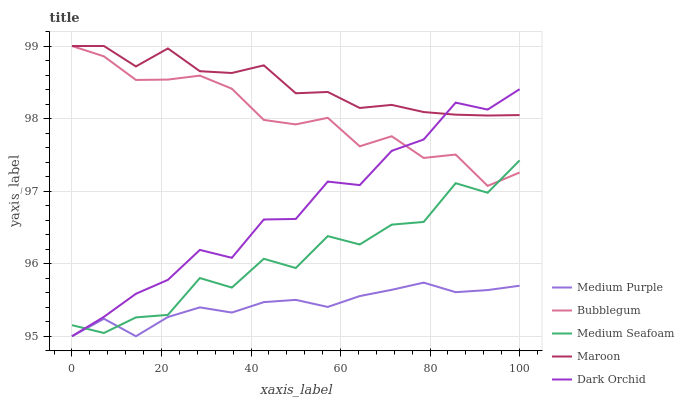Does Medium Purple have the minimum area under the curve?
Answer yes or no. Yes. Does Maroon have the maximum area under the curve?
Answer yes or no. Yes. Does Dark Orchid have the minimum area under the curve?
Answer yes or no. No. Does Dark Orchid have the maximum area under the curve?
Answer yes or no. No. Is Medium Purple the smoothest?
Answer yes or no. Yes. Is Medium Seafoam the roughest?
Answer yes or no. Yes. Is Maroon the smoothest?
Answer yes or no. No. Is Maroon the roughest?
Answer yes or no. No. Does Medium Purple have the lowest value?
Answer yes or no. Yes. Does Maroon have the lowest value?
Answer yes or no. No. Does Bubblegum have the highest value?
Answer yes or no. Yes. Does Dark Orchid have the highest value?
Answer yes or no. No. Is Medium Seafoam less than Maroon?
Answer yes or no. Yes. Is Bubblegum greater than Medium Purple?
Answer yes or no. Yes. Does Bubblegum intersect Medium Seafoam?
Answer yes or no. Yes. Is Bubblegum less than Medium Seafoam?
Answer yes or no. No. Is Bubblegum greater than Medium Seafoam?
Answer yes or no. No. Does Medium Seafoam intersect Maroon?
Answer yes or no. No. 